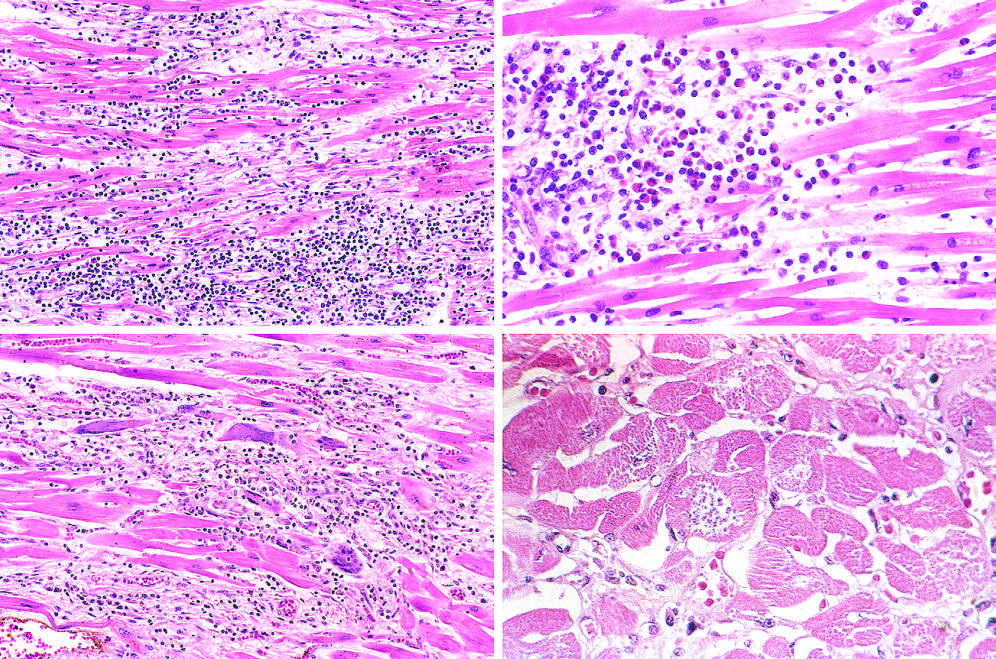what is a myofiber distended with trypanosomes presented along with?
Answer the question using a single word or phrase. Mononuclear inflammation and myofiber necrosis 